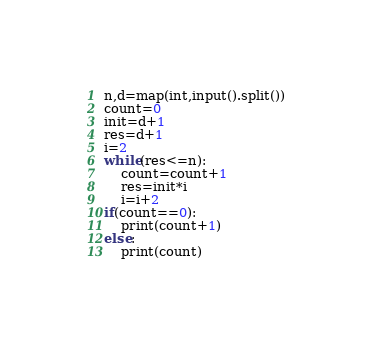Convert code to text. <code><loc_0><loc_0><loc_500><loc_500><_Python_>n,d=map(int,input().split())
count=0
init=d+1
res=d+1
i=2
while(res<=n):
	count=count+1
	res=init*i
	i=i+2
if(count==0):
    print(count+1)
else:
	print(count)</code> 